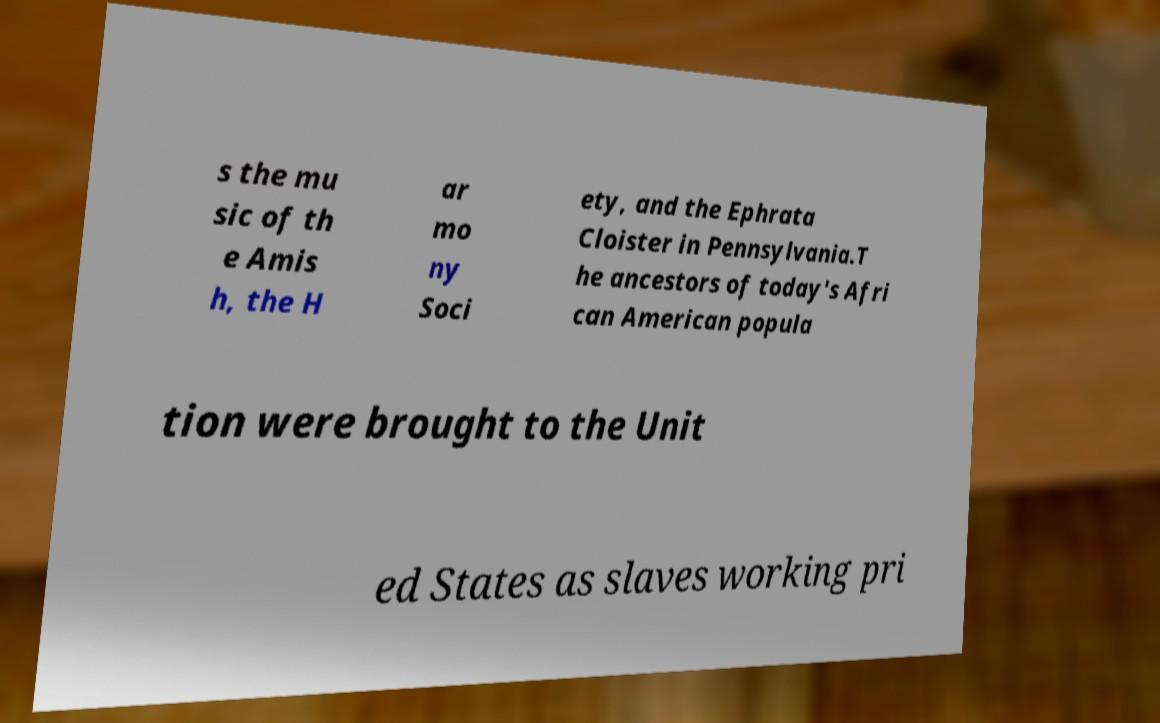For documentation purposes, I need the text within this image transcribed. Could you provide that? s the mu sic of th e Amis h, the H ar mo ny Soci ety, and the Ephrata Cloister in Pennsylvania.T he ancestors of today's Afri can American popula tion were brought to the Unit ed States as slaves working pri 